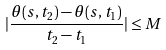<formula> <loc_0><loc_0><loc_500><loc_500>| \frac { \theta ( s , t _ { 2 } ) - \theta ( s , t _ { 1 } ) } { t _ { 2 } - t _ { 1 } } | \leq M</formula> 